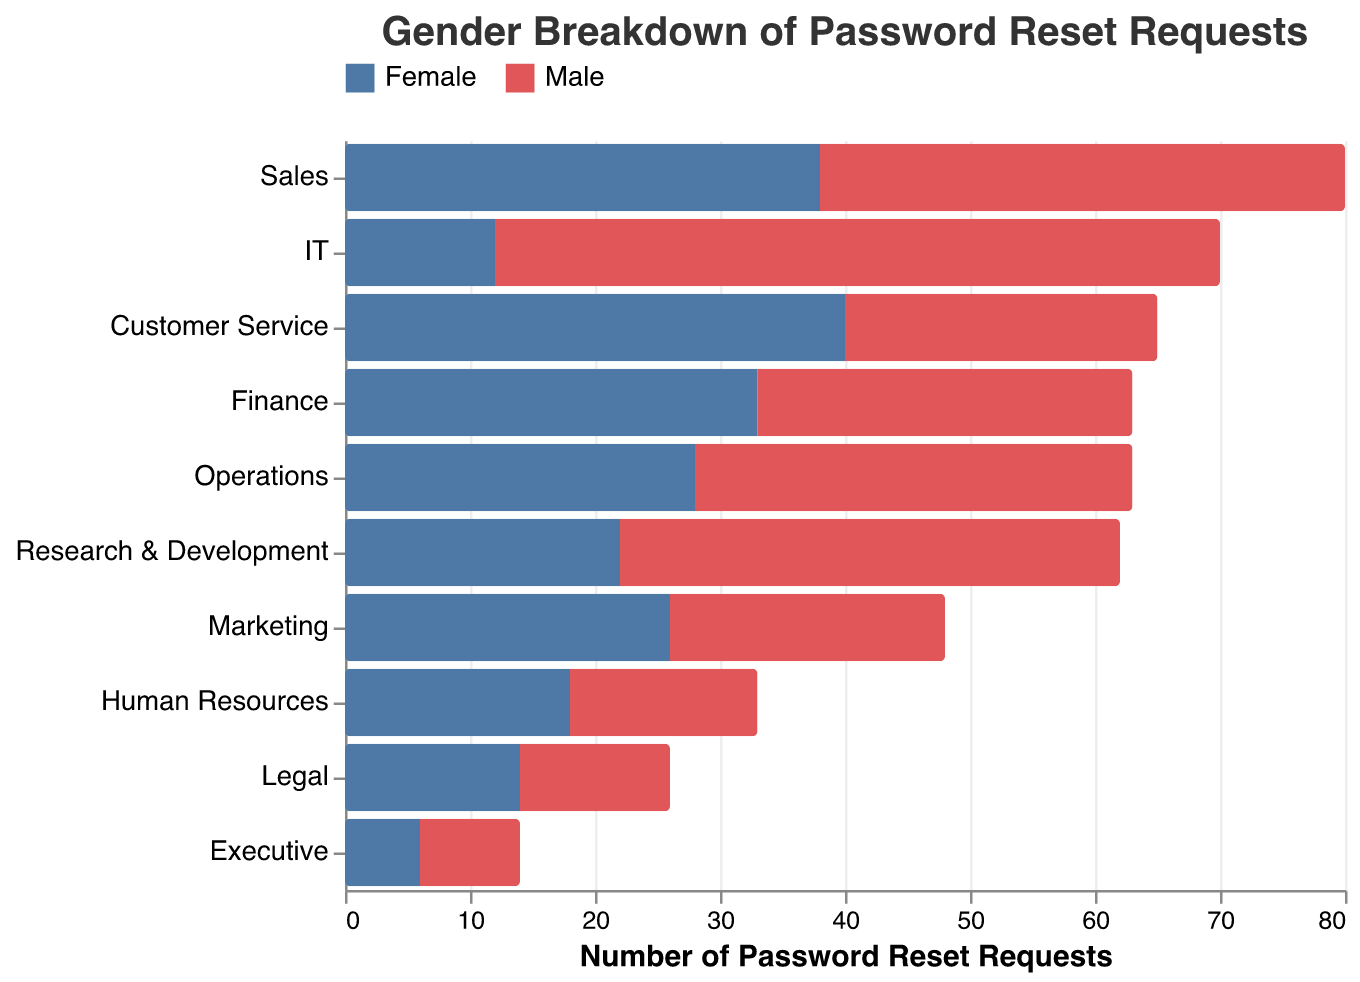How many password reset requests were made by females in the Customer Service department? To find the number of password reset requests made by females in the Customer Service department, look for the bar associated with 'Customer Service' and 'Female' and read the value.
Answer: 40 Which department had the highest number of password reset requests from males? Identify the longest bar on the negative (left) side labeled 'Male' across all departments. This will show the department with the most requests from males.
Answer: IT How many more password reset requests were there from females compared to males in the Sales department? Find the values for both males and females in Sales (males: -42, females: 38). Calculate the absolute difference: 42 - 38.
Answer: 4 Which department had the fewest total password reset requests? Summing the values of male and female requests for each department and identifying the department with the lowest total. Departments: Executive (-8 + 6), Legal (-12 + 14), etc. The smallest combined number is for Executive.
Answer: Executive In which department did females have more than double the number of password reset requests compared to males? Check the values for each department to see where the female requests are more than twice the male requests. For instance, in IT, males: -58 and females: 12. In Customer Service, males: -25 and females: 40 (40 > 2 * 25).
Answer: Customer Service What is the total number of password reset requests made by females across all departments? Sum the female values from all departments: 18 + 38 + 26 + 33 + 12 + 40 + 28 + 22 + 14 + 6.
Answer: 237 How does the ratio of password reset requests from males to females in the Marketing department compare? Compare the requests using the male and female values (male: -22, female: 26). The ratio of males to females is 22:26. Simplifying this, 22/26 = 11/13.
Answer: 11:13 How many more password reset requests were from males compared to females in the IT department? Find the difference between males and females in IT: males: -58, females: 12. Calculate: 58 - 12.
Answer: 46 